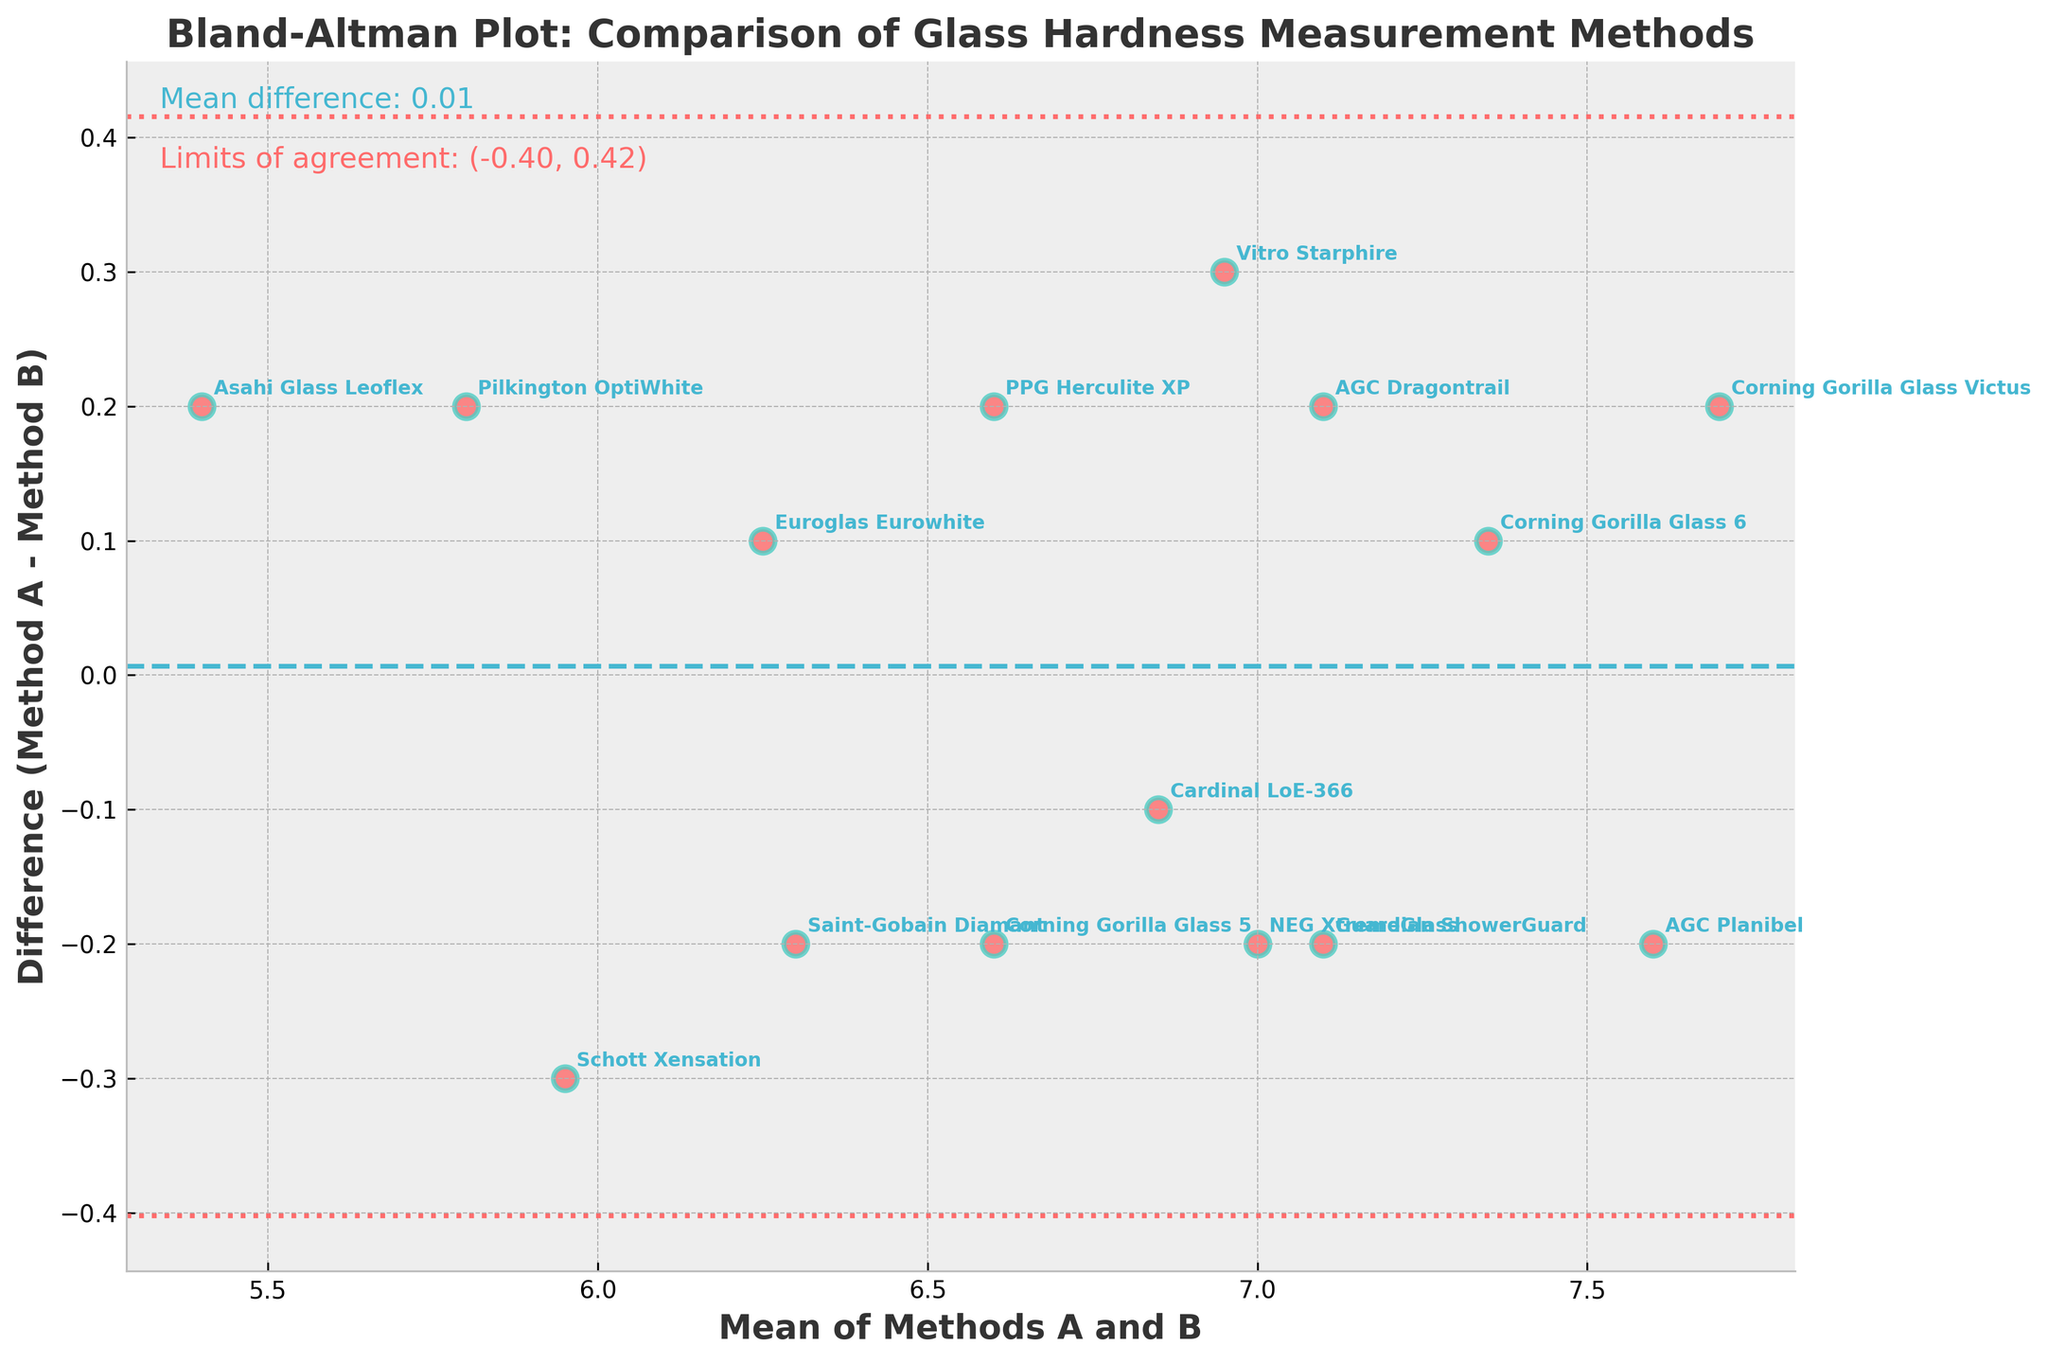how many data points are there in the plot? Count the total number of points (or products) annotated in the plot.
Answer: 15 What is the title of the plot? Look at the topmost text, which is usually the title in a plot.
Answer: Bland-Altman Plot: Comparison of Glass Hardness Measurement Methods What is the range of the x-axis (mean of Methods A and B)? Identify the lowest and highest values marked on the x-axis of the plot.
Answer: 5.5 to 7.5 What is the mean difference between Method A and Method B? Look at the text annotation or the horizontal dashed line in the center of the plot that marks the mean difference.
Answer: -0.06 Which product has the largest positive difference between Method A and Method B? Find the data point with the highest positive value on the y-axis (difference). Annotate the product name.
Answer: Corning Gorilla Glass 5 How many products have a negative difference (Method A - Method B)? Count the number of data points located below the zero line on the y-axis.
Answer: 7 What are the limits of agreement for the differences between Method A and Method B? Locate the dashed lines marking the limits of agreement and read the values from the text annotation.
Answer: (-0.32, 0.20) Which product has the closest mean value between Methods A and B? Identify the point closest to zero on the y-axis in terms of mean values (x-axis).
Answer: Corning Gorilla Glass 6 Are there any products outside the limits of agreement? Check if any points lie outside the dashed lines representing the limits of agreement.
Answer: No What is the mean value of the products tested with Method A and Method B? Calculate the average of all points on the x-axis which represents the mean of Method A and Method B. Sum all mean values and divide by the total number of points.
Answer: 6.73 